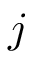<formula> <loc_0><loc_0><loc_500><loc_500>j</formula> 